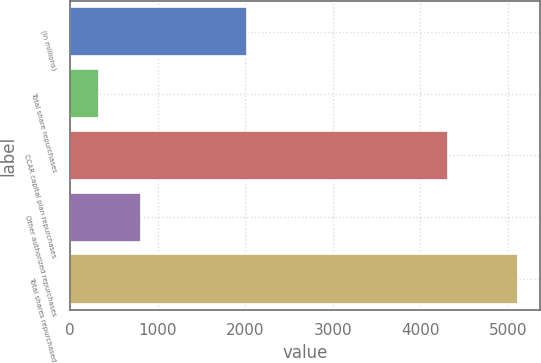Convert chart to OTSL. <chart><loc_0><loc_0><loc_500><loc_500><bar_chart><fcel>(in millions)<fcel>Total share repurchases<fcel>CCAR capital plan repurchases<fcel>Other authorized repurchases<fcel>Total shares repurchased<nl><fcel>2016<fcel>333<fcel>4312<fcel>810.9<fcel>5112<nl></chart> 